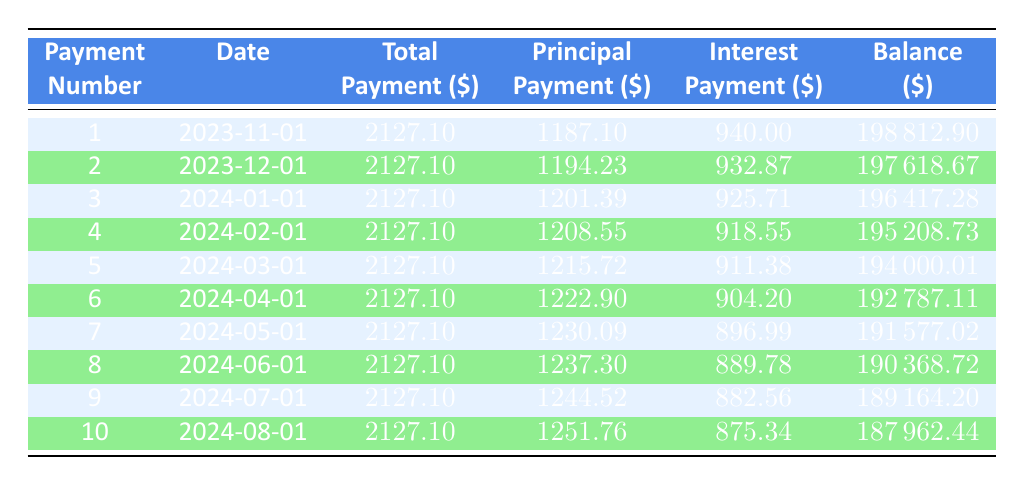What is the total payment for the first month? The first row of the table indicates the total payment for the first month (payment number 1) is 2127.10.
Answer: 2127.10 How much was paid towards the principal in the second payment? From the second row, the principal payment for the second payment (payment number 2) is listed as 1194.23.
Answer: 1194.23 What is the interest amount for the third payment? According to the third row of the table, the interest payment for the third payment (payment number 3) is 925.71.
Answer: 925.71 How much total payment has been made after the first three months? The total payments for the first three months are 2127.10 (first month) + 2127.10 (second month) + 2127.10 (third month) = 6381.30.
Answer: 6381.30 What is the remaining balance after the fourth payment? The remaining balance after the fourth payment (payment number 4) is shown in the fourth row as 195208.73.
Answer: 195208.73 Is the principal payment for the seventh month greater than the sixth month? From the sixth and seventh rows, the principal payments for the sixth and seventh months are 1222.90 and 1230.09, respectively. Since 1230.09 is greater than 1222.90, the statement is true.
Answer: Yes What is the average principal payment for the first ten payments? To find the average principal payment, sum the principal payments for all ten months and divide by 10. The sum of principal payments from each entry is 1187.10 + 1194.23 + 1201.39 + 1208.55 + 1215.72 + 1222.90 + 1230.09 + 1237.30 + 1244.52 + 1251.76 = 12200.56, which gives an average of 12200.56 / 10 = 1220.06.
Answer: 1220.06 What is the total interest payment made in the first five months? The total interest payment for the first five months is the sum of the interest payments from the first five rows: 940.00 + 932.87 + 925.71 + 918.55 + 911.38 = 4628.51.
Answer: 4628.51 Is the remaining balance after the second payment less than after the first payment? The remaining balance after the first payment is 198812.90, and after the second payment, it is 197618.67. Since 197618.67 is less than 198812.90, this statement is true.
Answer: Yes 